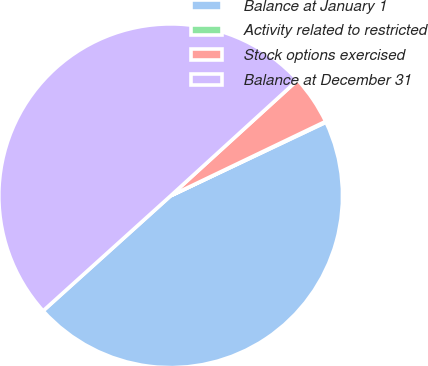Convert chart to OTSL. <chart><loc_0><loc_0><loc_500><loc_500><pie_chart><fcel>Balance at January 1<fcel>Activity related to restricted<fcel>Stock options exercised<fcel>Balance at December 31<nl><fcel>45.36%<fcel>0.08%<fcel>4.64%<fcel>49.92%<nl></chart> 